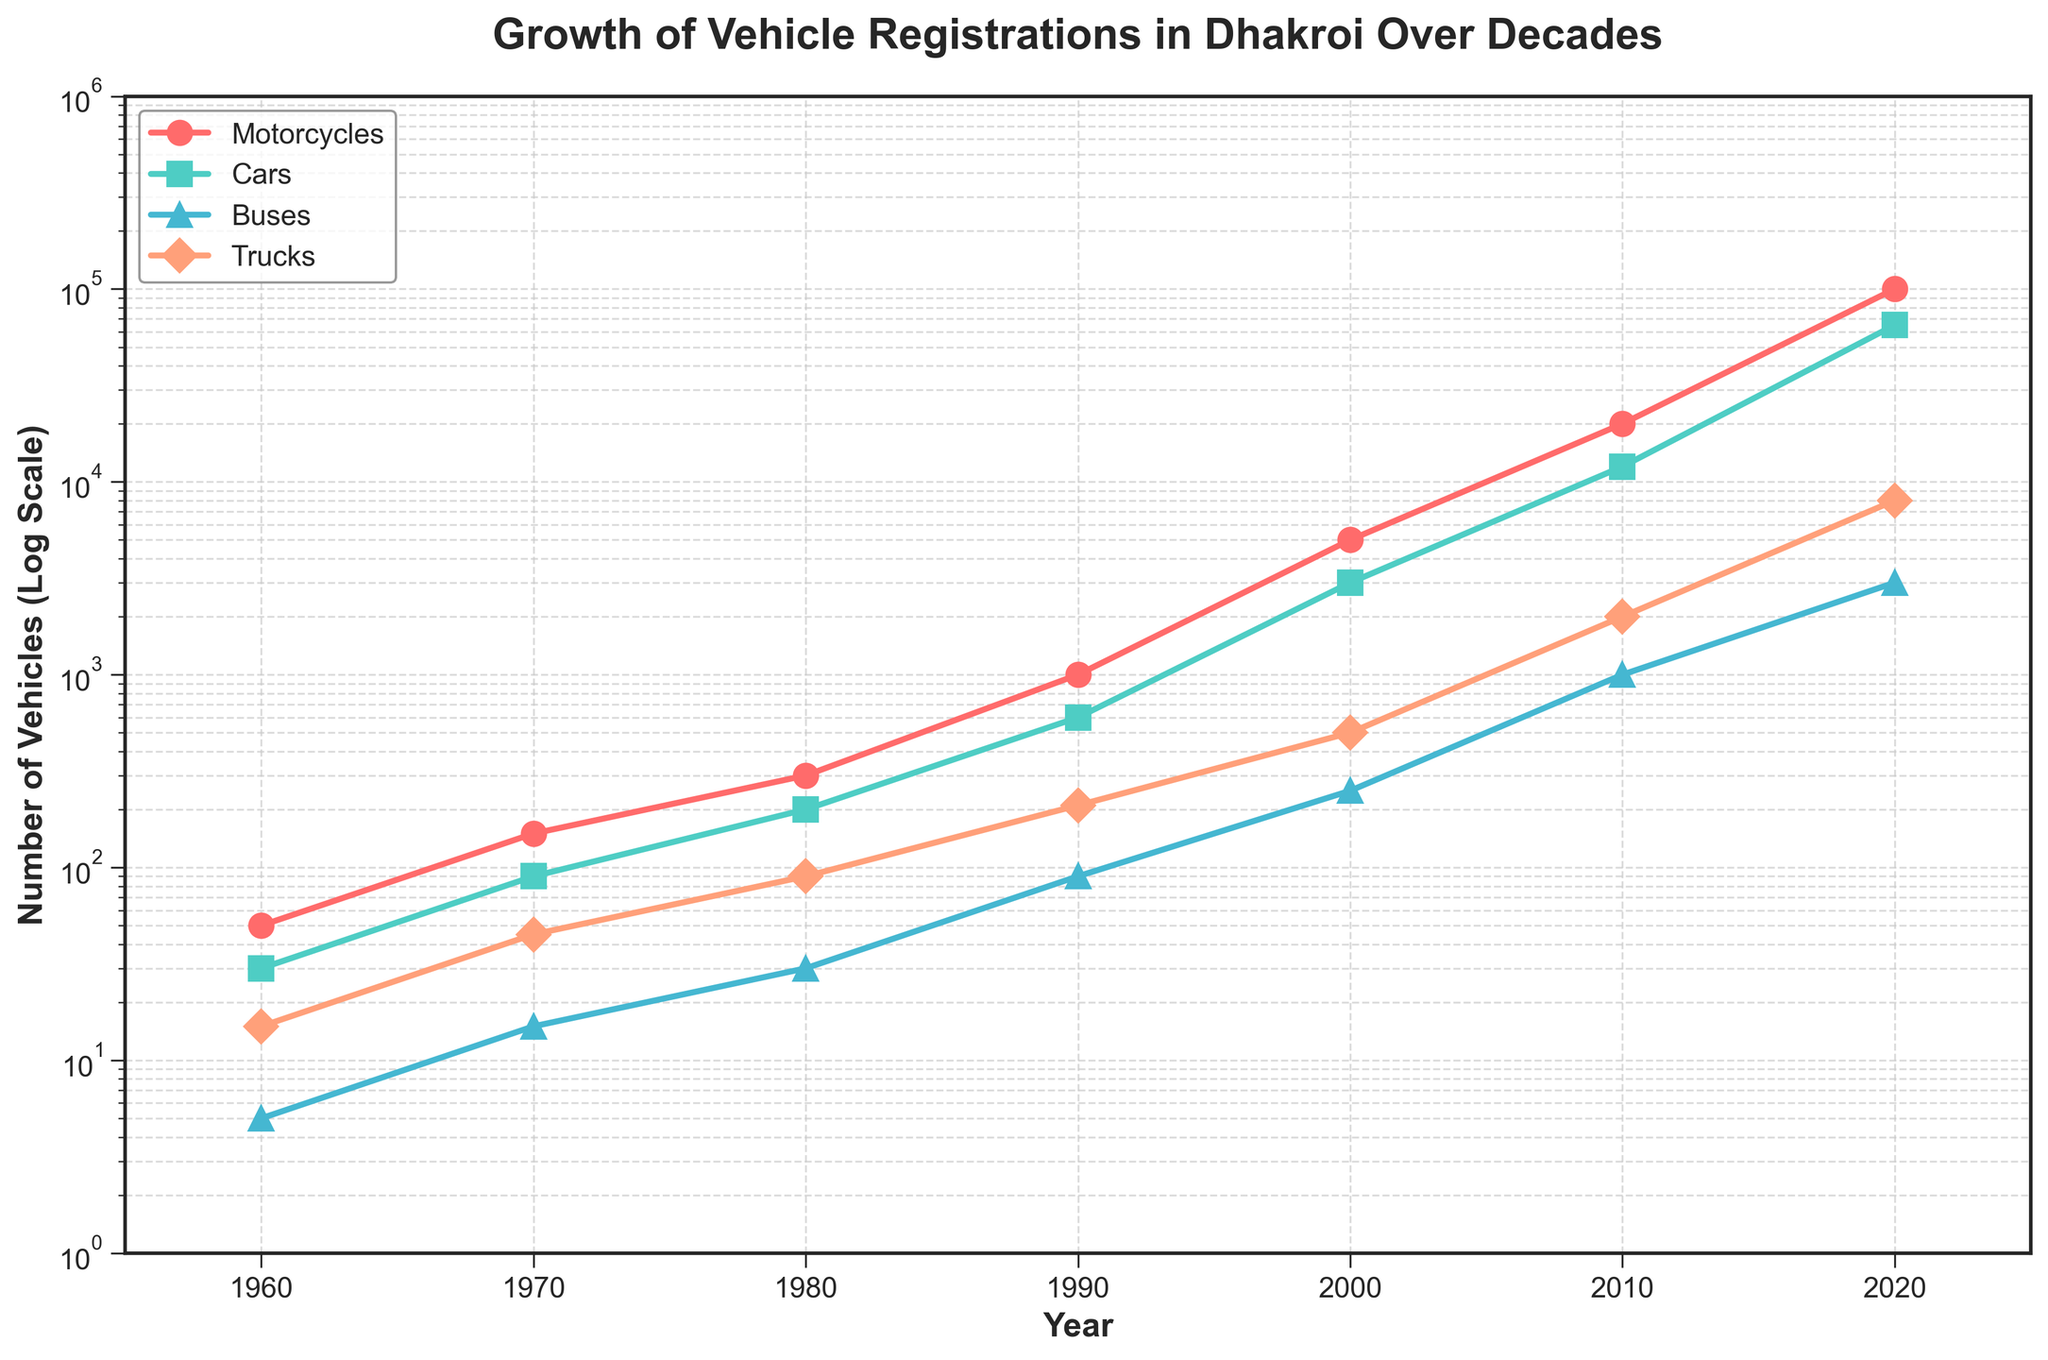What is the title of the plot? The title of the plot is located at the top of the figure, typically larger and bolded to stand out. It is a summary of what the plot represents.
Answer: Growth of Vehicle Registrations in Dhakroi Over Decades Which type of vehicle had the most registrations in 2020? To find this, look at the values for each type of vehicle in the year 2020 on the x-axis. The highest value on the y-axis log scale will indicate the most registrations.
Answer: Motorcycles What's the range of years displayed on the x-axis? The x-axis range is shown by the labels at both ends. The plot starts from the earliest year to the latest year marked on the x-axis.
Answer: 1955 to 2025 How many vehicle types are displayed in the plot? The vehicle types can be identified by the different lines and markers in the plot, each representing a specific vehicle type. The legend also lists all the vehicle types.
Answer: Four Compare the growth trends of motorcycles and cars. Which grew faster between 2000 and 2020? Look at the slopes of the lines for motorcycles and cars between the years 2000 and 2020. The steeper the slope, the faster the growth.
Answer: Motorcycles Between which two consecutive decades did trucks see the highest increase in registrations? Look at the plotted data points for trucks and identify the two consecutive decades with the largest vertical difference on the log scale.
Answer: 2010 to 2020 What is the approximate number of buses registered in 1990? Locate the data point for buses in the year 1990 on the x-axis and the corresponding value on the y-axis log scale.
Answer: 90 How does the registration of cars in 2000 compare to motorcycles in 1980? Locate both data points for cars in 2000 and motorcycles in 1980 and compare their positions on the y-axis log scale.
Answer: Cars in 2000 were higher By how many times did motorcycle registrations increase from 1970 to 2020? To determine the fold increase, divide the number of motorcycle registrations in 2020 by those in 1970.
Answer: 666.67 times 